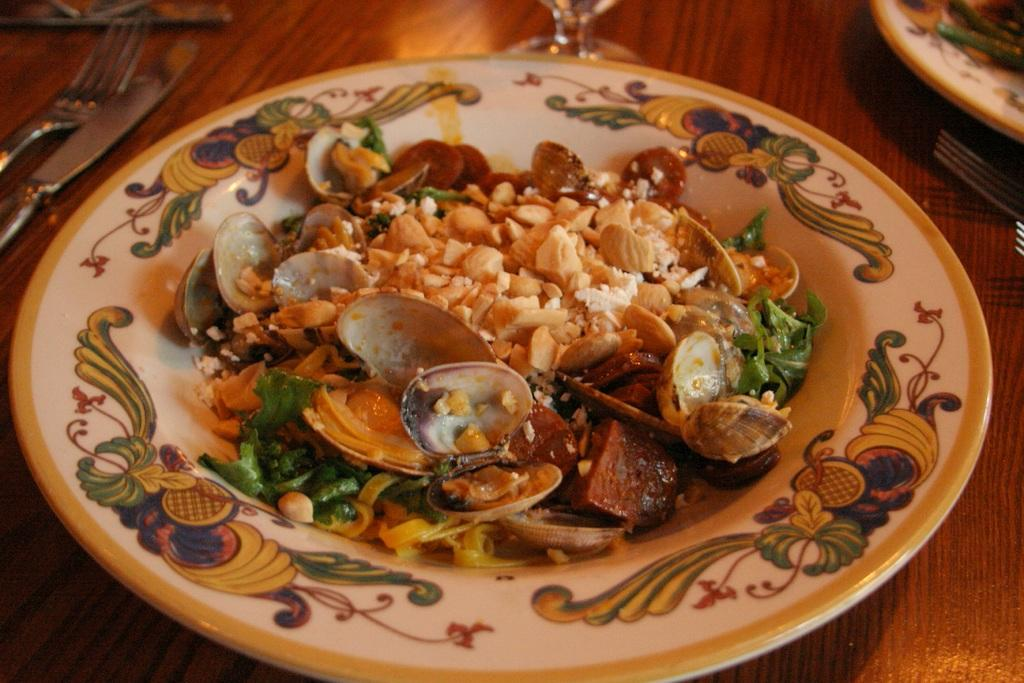What type of surface is visible in the image? There is a wooden surface in the image. What is placed on the wooden surface? There is a plate on the wooden surface. What is in the plate? There is food in the plate. What utensils are present in the image? There is a fork and a knife in the image. What type of glassware is visible in the image? There is a wine glass in the image. Where is the control panel for the meeting located in the image? There is no control panel or meeting present in the image; it features a wooden surface with a plate, food, utensils, and a wine glass. What type of stick is used to stir the food in the image? There is no stick present in the image; the utensils visible are a fork and a knife. 